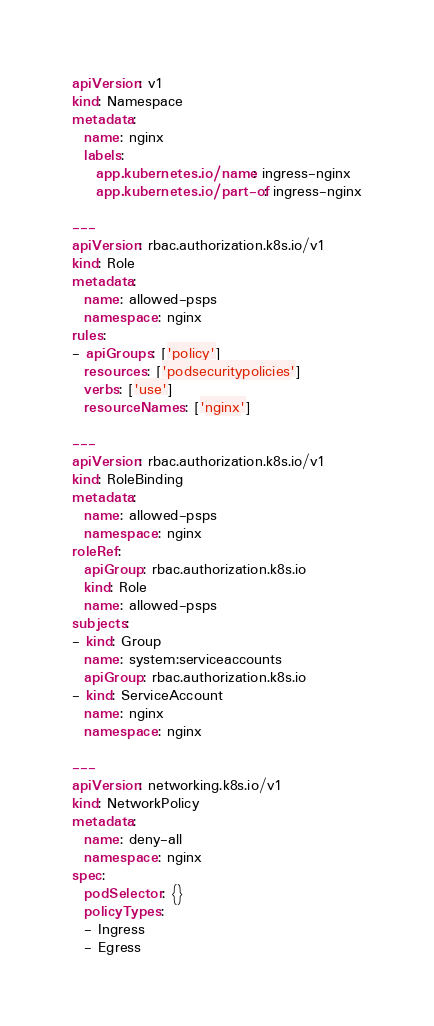Convert code to text. <code><loc_0><loc_0><loc_500><loc_500><_YAML_>apiVersion: v1
kind: Namespace
metadata:
  name: nginx
  labels:
    app.kubernetes.io/name: ingress-nginx
    app.kubernetes.io/part-of: ingress-nginx

---
apiVersion: rbac.authorization.k8s.io/v1
kind: Role
metadata:
  name: allowed-psps
  namespace: nginx
rules:
- apiGroups: ['policy']
  resources: ['podsecuritypolicies']
  verbs: ['use']
  resourceNames: ['nginx']

---
apiVersion: rbac.authorization.k8s.io/v1
kind: RoleBinding
metadata:
  name: allowed-psps
  namespace: nginx
roleRef:
  apiGroup: rbac.authorization.k8s.io
  kind: Role
  name: allowed-psps
subjects:
- kind: Group
  name: system:serviceaccounts
  apiGroup: rbac.authorization.k8s.io
- kind: ServiceAccount
  name: nginx
  namespace: nginx

---
apiVersion: networking.k8s.io/v1
kind: NetworkPolicy
metadata:
  name: deny-all
  namespace: nginx
spec:
  podSelector: {}
  policyTypes:
  - Ingress
  - Egress
</code> 